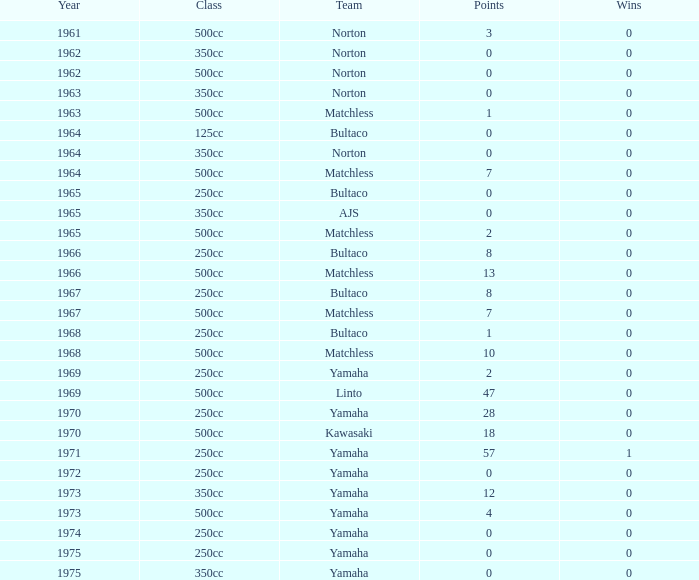Could you parse the entire table as a dict? {'header': ['Year', 'Class', 'Team', 'Points', 'Wins'], 'rows': [['1961', '500cc', 'Norton', '3', '0'], ['1962', '350cc', 'Norton', '0', '0'], ['1962', '500cc', 'Norton', '0', '0'], ['1963', '350cc', 'Norton', '0', '0'], ['1963', '500cc', 'Matchless', '1', '0'], ['1964', '125cc', 'Bultaco', '0', '0'], ['1964', '350cc', 'Norton', '0', '0'], ['1964', '500cc', 'Matchless', '7', '0'], ['1965', '250cc', 'Bultaco', '0', '0'], ['1965', '350cc', 'AJS', '0', '0'], ['1965', '500cc', 'Matchless', '2', '0'], ['1966', '250cc', 'Bultaco', '8', '0'], ['1966', '500cc', 'Matchless', '13', '0'], ['1967', '250cc', 'Bultaco', '8', '0'], ['1967', '500cc', 'Matchless', '7', '0'], ['1968', '250cc', 'Bultaco', '1', '0'], ['1968', '500cc', 'Matchless', '10', '0'], ['1969', '250cc', 'Yamaha', '2', '0'], ['1969', '500cc', 'Linto', '47', '0'], ['1970', '250cc', 'Yamaha', '28', '0'], ['1970', '500cc', 'Kawasaki', '18', '0'], ['1971', '250cc', 'Yamaha', '57', '1'], ['1972', '250cc', 'Yamaha', '0', '0'], ['1973', '350cc', 'Yamaha', '12', '0'], ['1973', '500cc', 'Yamaha', '4', '0'], ['1974', '250cc', 'Yamaha', '0', '0'], ['1975', '250cc', 'Yamaha', '0', '0'], ['1975', '350cc', 'Yamaha', '0', '0']]} What is the sum of all points in 1975 with 0 wins? None. 